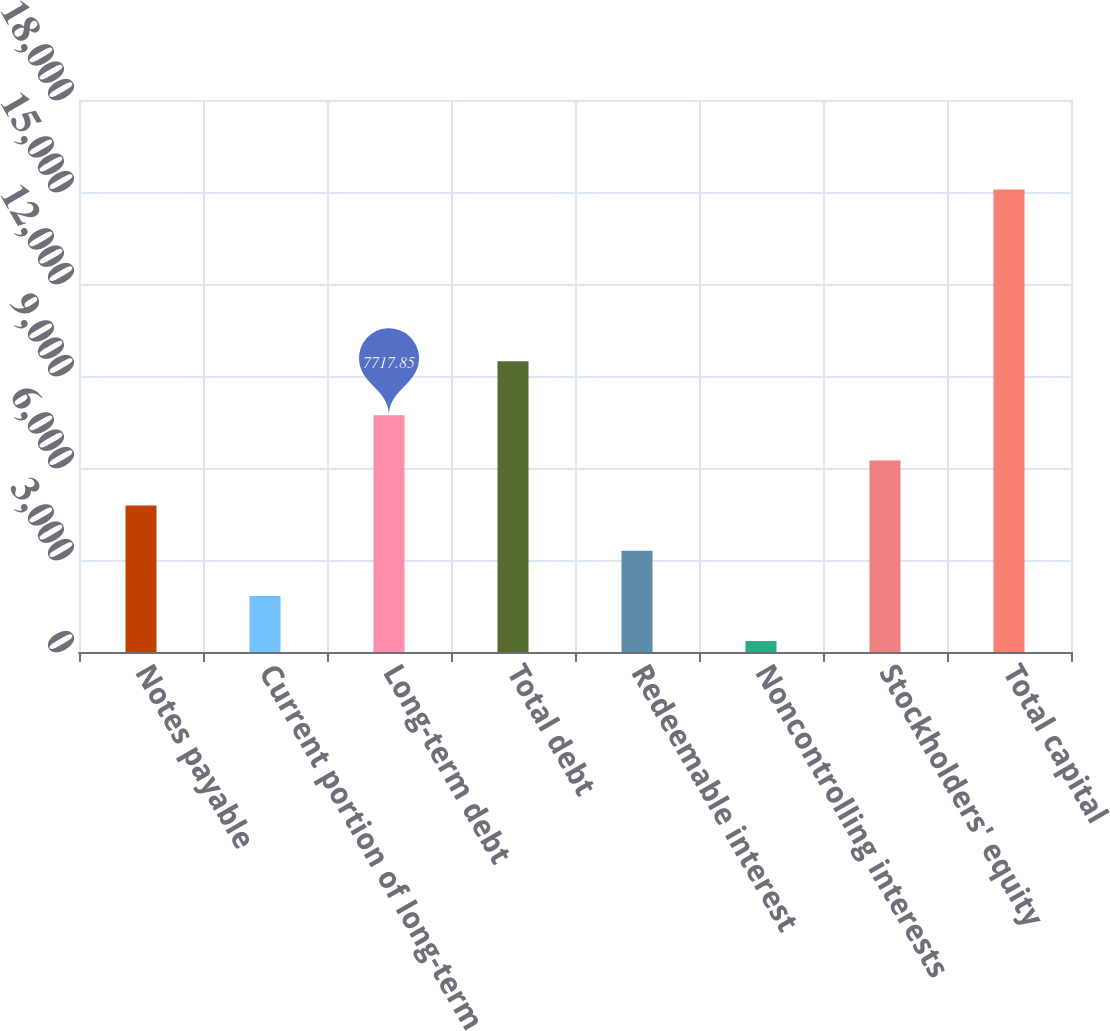Convert chart to OTSL. <chart><loc_0><loc_0><loc_500><loc_500><bar_chart><fcel>Notes payable<fcel>Current portion of long-term<fcel>Long-term debt<fcel>Total debt<fcel>Redeemable interest<fcel>Noncontrolling interests<fcel>Stockholders' equity<fcel>Total capital<nl><fcel>4773.75<fcel>1829.65<fcel>7717.85<fcel>9481.7<fcel>3301.7<fcel>357.6<fcel>6245.8<fcel>15078.1<nl></chart> 